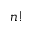<formula> <loc_0><loc_0><loc_500><loc_500>n !</formula> 